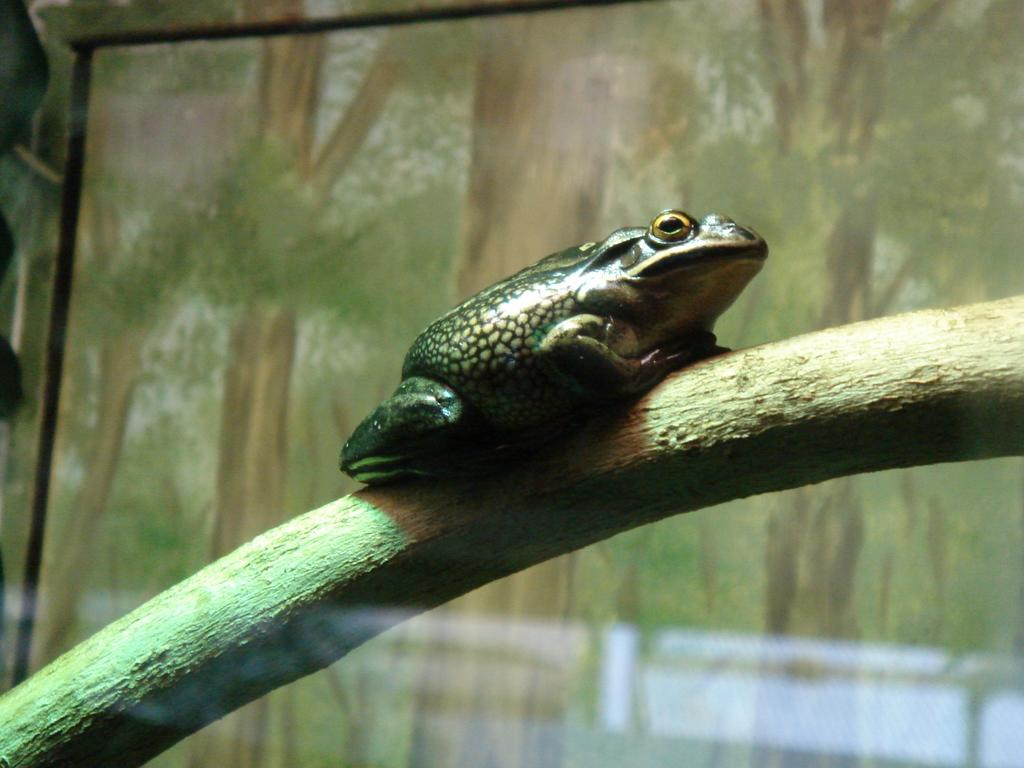What animal is present in the image? There is a frog in the image. Where is the frog located? The frog is on a branch. What can be seen in the background of the image? There is a background in the image that resembles a screen, and many trees are visible in the background. What type of current is flowing through the image? There is no current present in the image; it is a still image of a frog on a branch. 